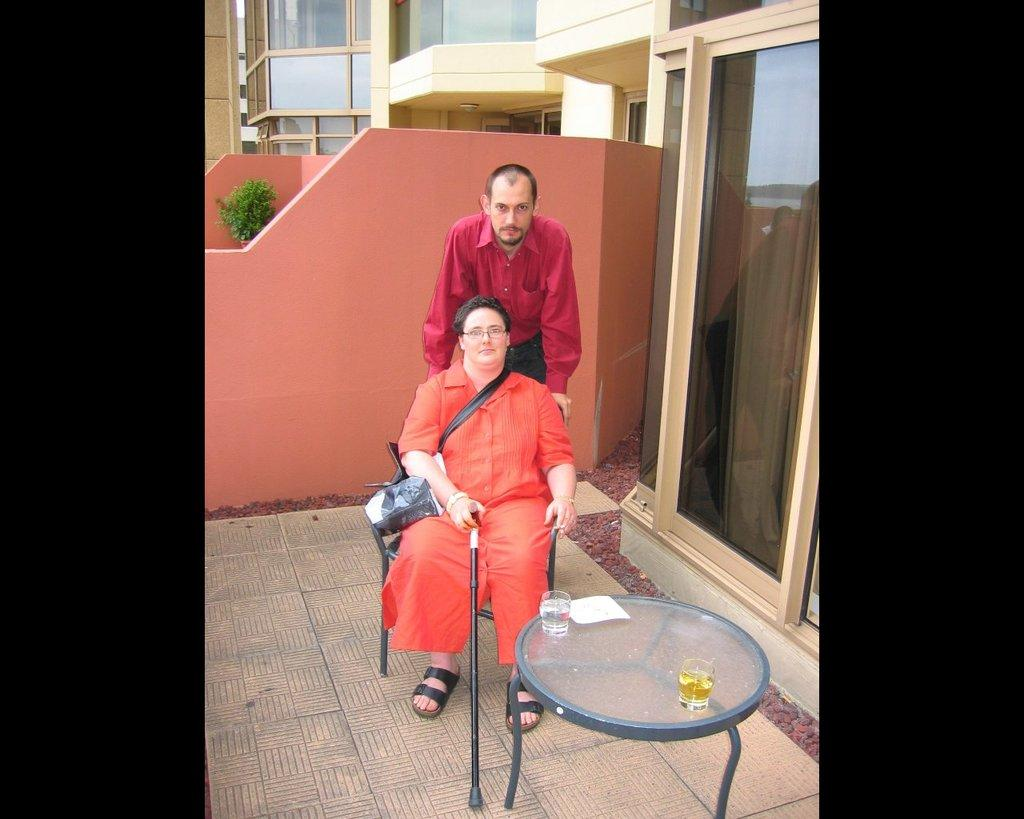What is the woman doing in the image? There is a woman sitting in the image. What is the man doing in the image? There is a man standing in the image. What objects are on the table in the image? There are two wine glasses on the table in the image. Can you see the woman's mom in the image? There is no mention of the woman's mom in the image, so we cannot determine if she is present or not. 